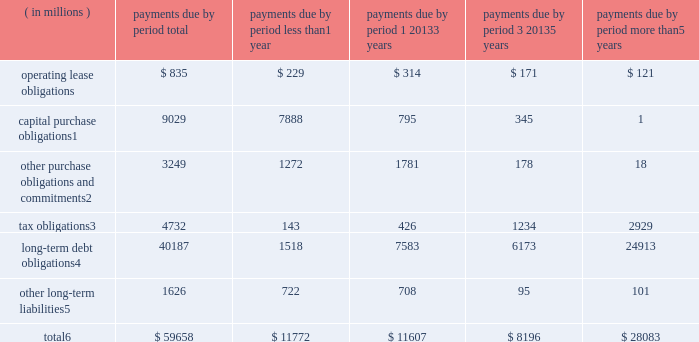Contractual obligations significant contractual obligations as of december 29 , 2018 were as follows: .
Capital purchase obligations1 9029 7888 795 345 1 other purchase obligations and commitments2 3249 1272 1781 178 18 tax obligations3 4732 143 426 1234 2929 long-term debt obligations4 40187 1518 7583 6173 24913 other long-term liabilities5 1626 722 708 95 101 total6 $ 59658 $ 11772 $ 11607 $ 8196 $ 28083 1 capital purchase obligations represent commitments for the construction or purchase of property , plant and equipment .
They were not recorded as liabilities on our consolidated balance sheets as of december 29 , 2018 , as we had not yet received the related goods nor taken title to the property .
2 other purchase obligations and commitments include payments due under various types of licenses and agreements to purchase goods or services , as well as payments due under non-contingent funding obligations .
3 tax obligations represent the future cash payments related to tax reform enacted in 2017 for the one-time transition tax on our previously untaxed foreign earnings .
For further information , see 201cnote 9 : income taxes 201d within the consolidated financial statements .
4 amounts represent principal payments for all debt obligations and interest payments for fixed-rate debt obligations .
Interest payments on floating-rate debt obligations , as well as the impact of fixed-rate to floating-rate debt swaps , are excluded .
Debt obligations are classified based on their stated maturity date , regardless of their classification on the consolidated balance sheets .
Any future settlement of convertible debt would impact our cash payments .
5 amounts represent future cash payments to satisfy other long-term liabilities recorded on our consolidated balance sheets , including the short-term portion of these long-term liabilities .
Derivative instruments are excluded from the preceding table , as they do not represent the amounts that may ultimately be paid .
6 total excludes contractual obligations already recorded on our consolidated balance sheets as current liabilities , except for the short-term portions of long-term debt obligations and other long-term liabilities .
The expected timing of payments of the obligations in the preceding table is estimated based on current information .
Timing of payments and actual amounts paid may be different , depending on the time of receipt of goods or services , or changes to agreed- upon amounts for some obligations .
Contractual obligations for purchases of goods or services included in 201cother purchase obligations and commitments 201d in the preceding table include agreements that are enforceable and legally binding and that specify all significant terms , including fixed or minimum quantities to be purchased ; fixed , minimum , or variable price provisions ; and the approximate timing of the transaction .
For obligations with cancellation provisions , the amounts included in the preceding table were limited to the non-cancelable portion of the agreement terms or the minimum cancellation fee .
For the purchase of raw materials , we have entered into certain agreements that specify minimum prices and quantities based on a percentage of the total available market or based on a percentage of our future purchasing requirements .
Due to the uncertainty of the future market and our future purchasing requirements , as well as the non-binding nature of these agreements , obligations under these agreements have been excluded from the preceding table .
Our purchase orders for other products are based on our current manufacturing needs and are fulfilled by our vendors within short time horizons .
In addition , some of our purchase orders represent authorizations to purchase rather than binding agreements .
Contractual obligations that are contingent upon the achievement of certain milestones have been excluded from the preceding table .
Most of our milestone-based contracts are tooling related for the purchase of capital equipment .
These arrangements are not considered contractual obligations until the milestone is met by the counterparty .
As of december 29 , 2018 , assuming that all future milestones are met , the additional required payments would be approximately $ 688 million .
For the majority of restricted stock units ( rsus ) granted , the number of shares of common stock issued on the date the rsus vest is net of the minimum statutory withholding requirements that we pay in cash to the appropriate taxing authorities on behalf of our employees .
The obligation to pay the relevant taxing authority is excluded from the preceding table , as the amount is contingent upon continued employment .
In addition , the amount of the obligation is unknown , as it is based in part on the market price of our common stock when the awards vest .
Md&a consolidated results and analysis 42 .
What percentage of total contractual obligations as of december 29 , 2018 are due to capital purchase obligations? 
Computations: (9029 / 59658)
Answer: 0.15135. 